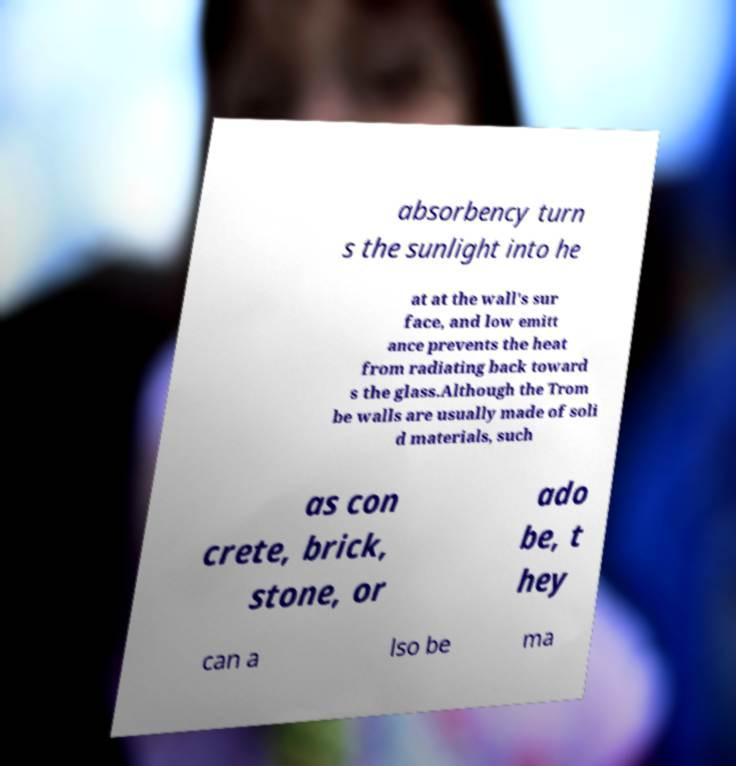Can you accurately transcribe the text from the provided image for me? absorbency turn s the sunlight into he at at the wall's sur face, and low emitt ance prevents the heat from radiating back toward s the glass.Although the Trom be walls are usually made of soli d materials, such as con crete, brick, stone, or ado be, t hey can a lso be ma 